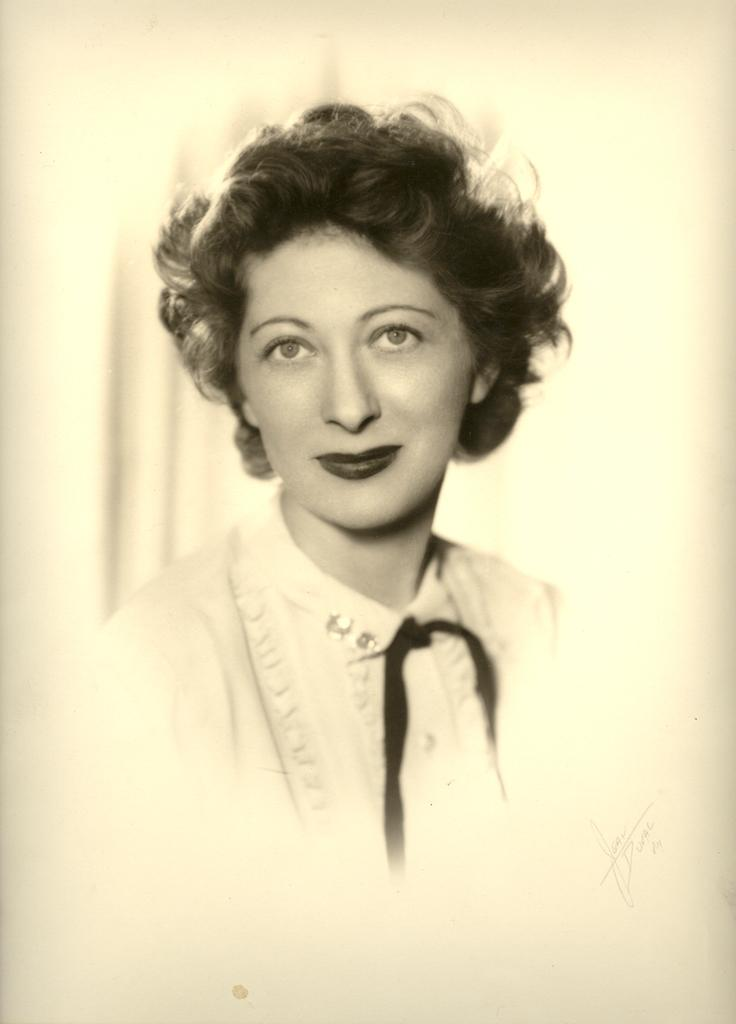What is the main subject of the image? There is a picture of a woman in the image. How is the woman in the image described? The woman is described as beautiful. What is the woman wearing in the image? The woman is wearing a collar neck dress. What type of ghost can be seen interacting with the woman in the image? There is no ghost present in the image; it features a picture of a woman wearing a collar neck dress. What kind of pot is visible in the image? There is no pot present in the image. 